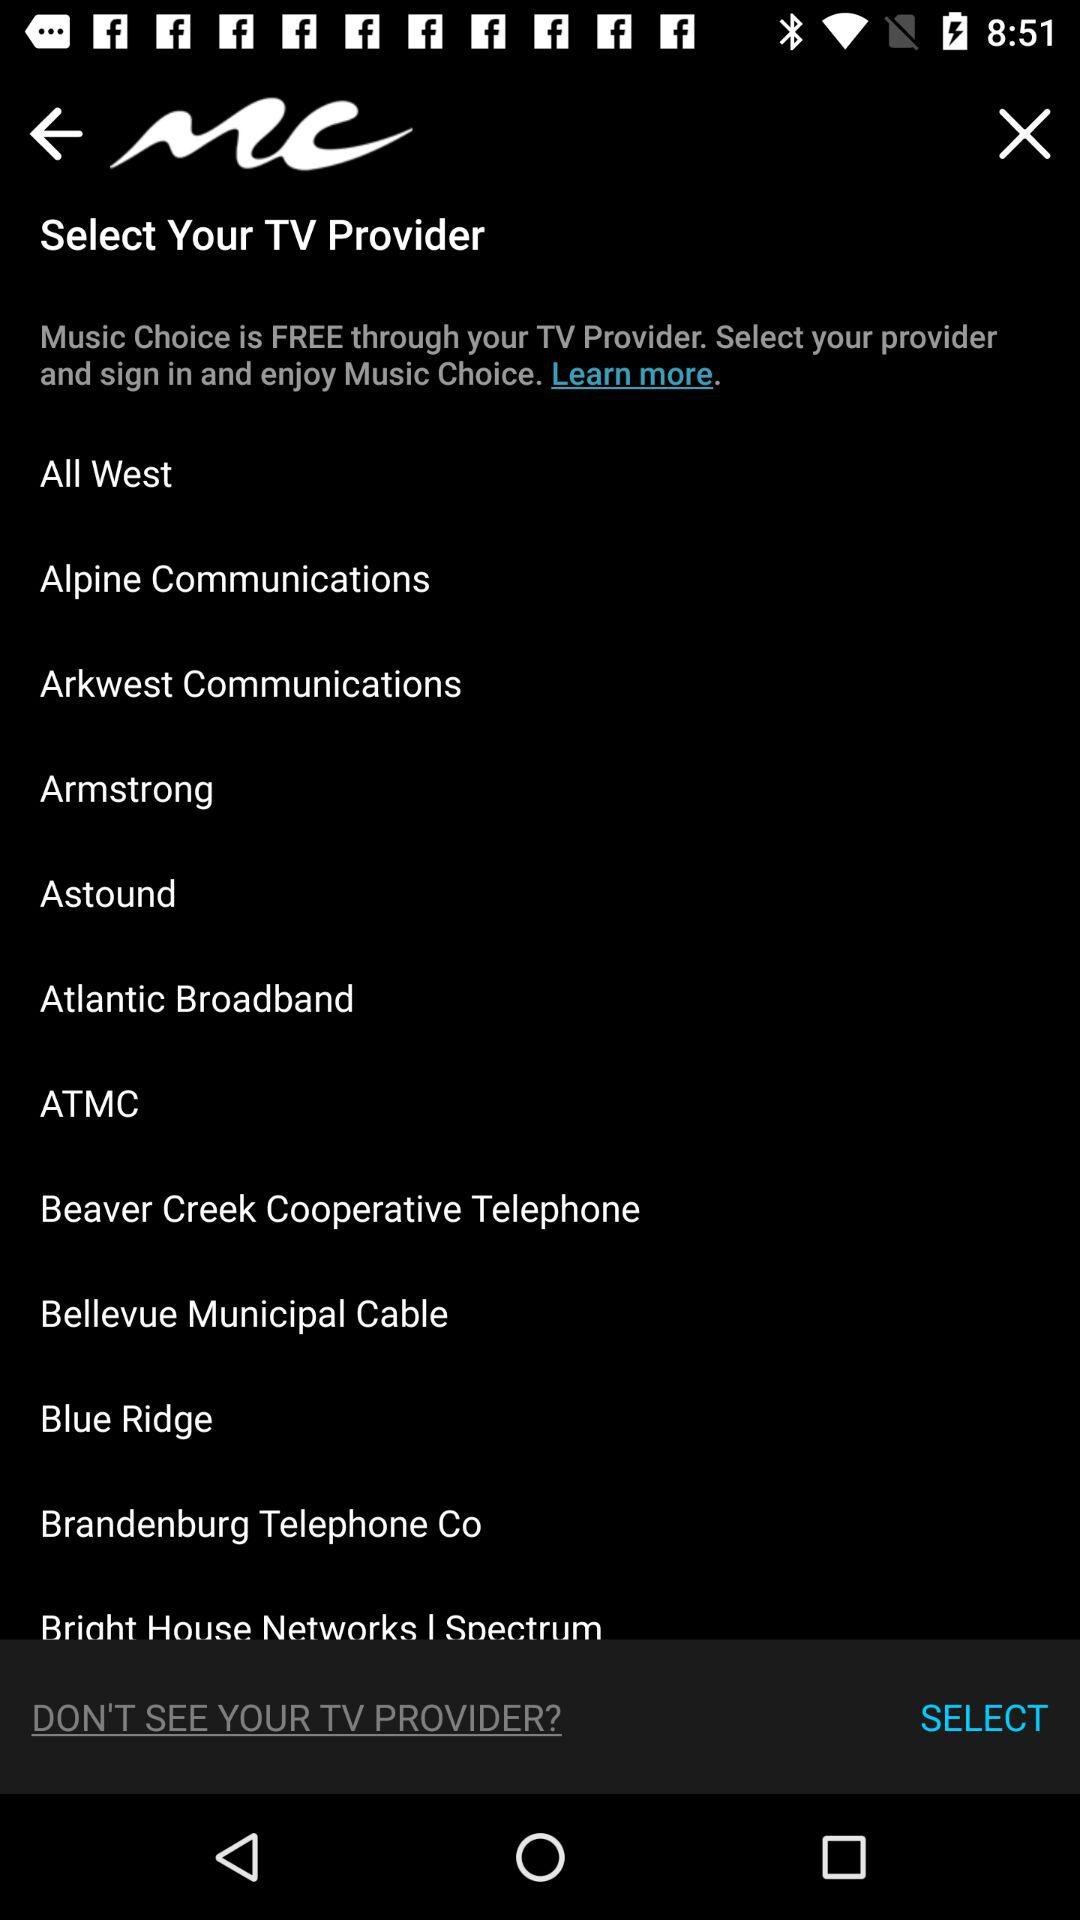How many TV providers are available? The available TV providers are "All West", "Alpine Communications", "Arkwest Communications", "Armstrong", "Astound", "Atlantic Broadband", "ATMC", "Beaver Creek Cooperative Telephone", "Bellevue Municipal Cable", "Blue Ridge", "Brandenburg Telephone Co" and "Bright House Networks I Spectrum". 